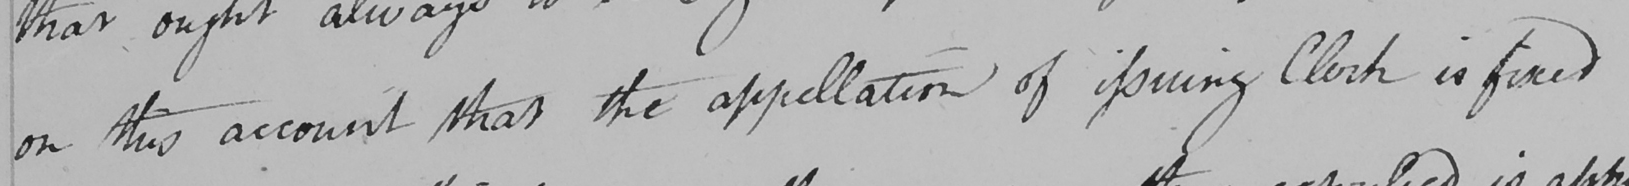Please provide the text content of this handwritten line. on this account that the appellation of issuing Clerk is fixed 